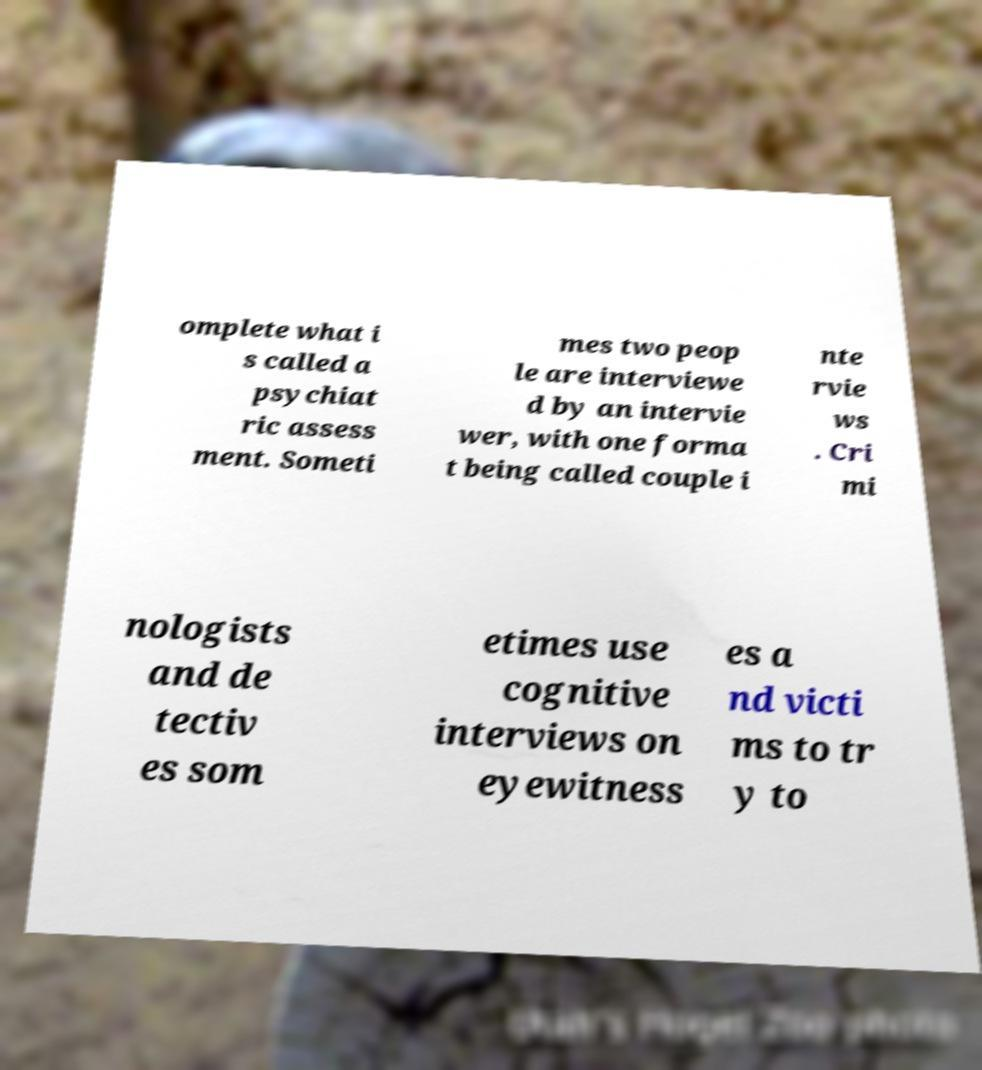Could you assist in decoding the text presented in this image and type it out clearly? omplete what i s called a psychiat ric assess ment. Someti mes two peop le are interviewe d by an intervie wer, with one forma t being called couple i nte rvie ws . Cri mi nologists and de tectiv es som etimes use cognitive interviews on eyewitness es a nd victi ms to tr y to 